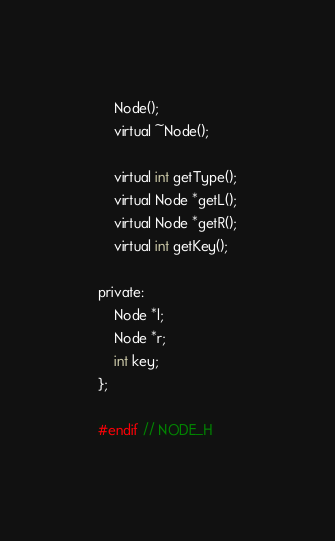<code> <loc_0><loc_0><loc_500><loc_500><_C_>    Node();
    virtual ~Node();

    virtual int getType();
    virtual Node *getL();
    virtual Node *getR();
    virtual int getKey();

private:
    Node *l;
    Node *r;
    int key;
};

#endif // NODE_H
</code> 